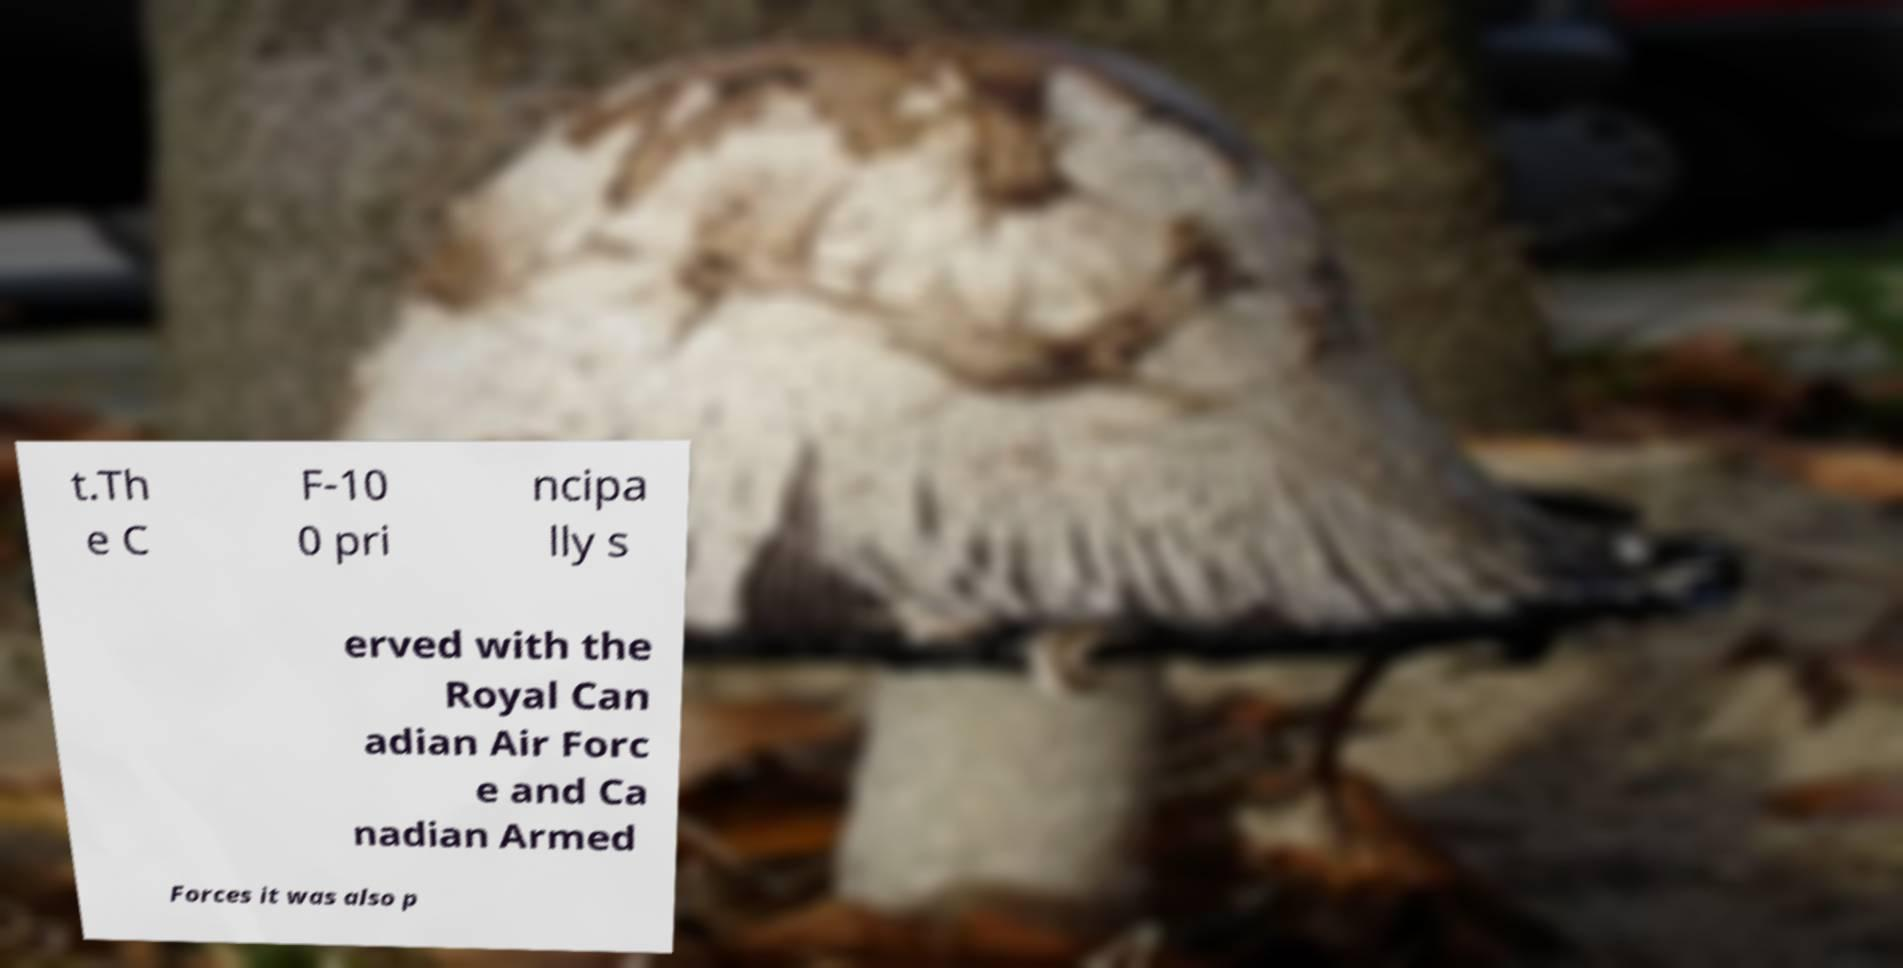Can you accurately transcribe the text from the provided image for me? t.Th e C F-10 0 pri ncipa lly s erved with the Royal Can adian Air Forc e and Ca nadian Armed Forces it was also p 